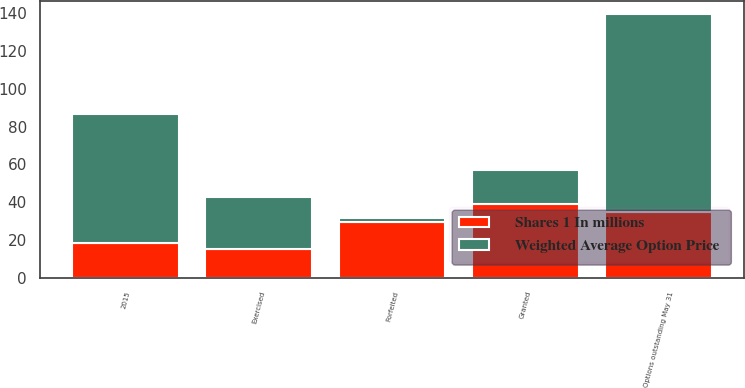Convert chart. <chart><loc_0><loc_0><loc_500><loc_500><stacked_bar_chart><ecel><fcel>Options outstanding May 31<fcel>Exercised<fcel>Forfeited<fcel>Granted<fcel>2015<nl><fcel>Weighted Average Option Price<fcel>104.8<fcel>27.2<fcel>2.1<fcel>18.4<fcel>68.6<nl><fcel>Shares 1 In millions<fcel>34.79<fcel>15.39<fcel>29.51<fcel>38.84<fcel>18.26<nl></chart> 